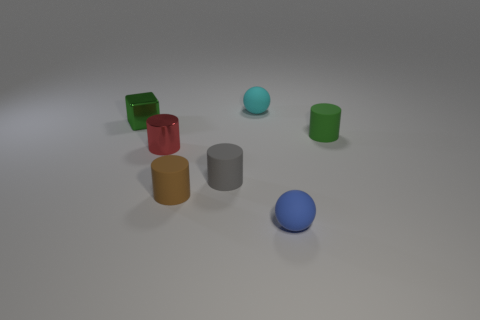Subtract 1 cylinders. How many cylinders are left? 3 Add 1 green matte cylinders. How many objects exist? 8 Subtract all cubes. How many objects are left? 6 Add 1 large blue metal objects. How many large blue metal objects exist? 1 Subtract 0 purple cubes. How many objects are left? 7 Subtract all green metal objects. Subtract all big things. How many objects are left? 6 Add 6 small green cubes. How many small green cubes are left? 7 